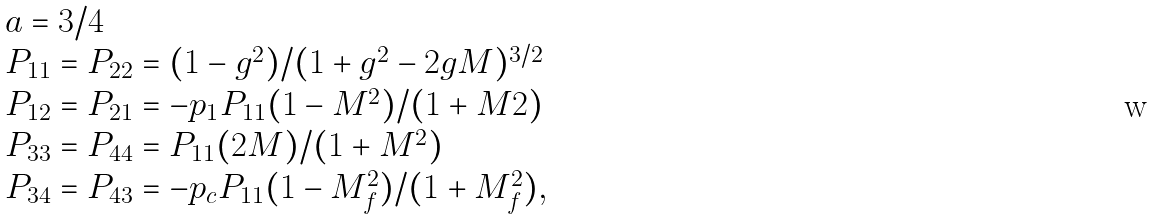Convert formula to latex. <formula><loc_0><loc_0><loc_500><loc_500>\begin{array} { l } a = 3 / 4 \\ P _ { 1 1 } = P _ { 2 2 } = ( 1 - g ^ { 2 } ) / ( 1 + g ^ { 2 } - 2 g M ) ^ { 3 / 2 } \\ P _ { 1 2 } = P _ { 2 1 } = - p _ { 1 } P _ { 1 1 } ( 1 - M ^ { 2 } ) / ( 1 + M 2 ) \\ P _ { 3 3 } = P _ { 4 4 } = P _ { 1 1 } ( 2 M ) / ( 1 + M ^ { 2 } ) \\ P _ { 3 4 } = P _ { 4 3 } = - p _ { c } P _ { 1 1 } ( 1 - M _ { f } ^ { 2 } ) / ( 1 + M _ { f } ^ { 2 } ) , \end{array}</formula> 